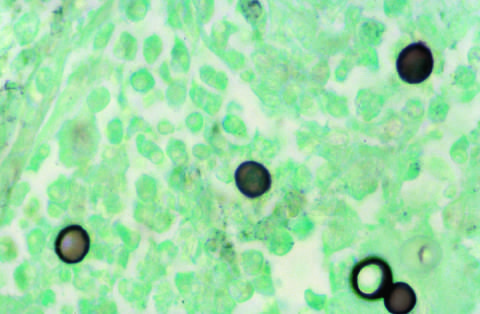what does silver stain highlight?
Answer the question using a single word or phrase. The broad-based budding seen in blastomyces immitis organisms 